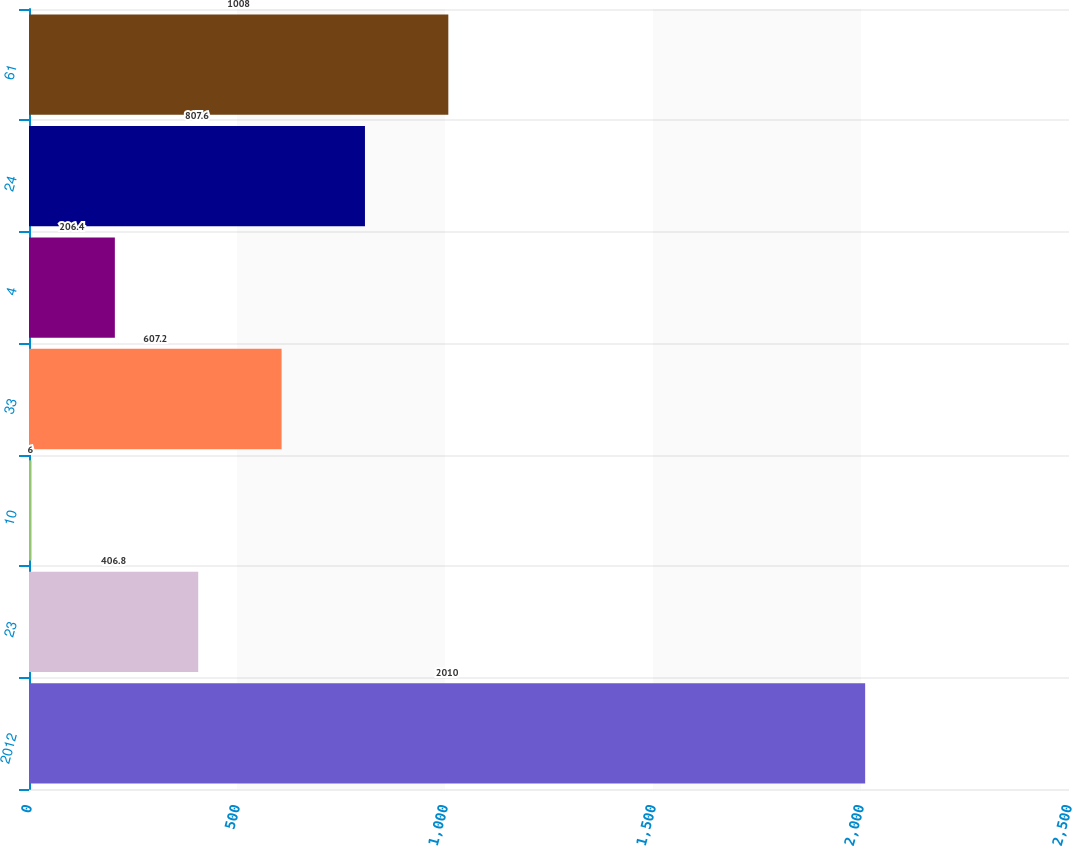<chart> <loc_0><loc_0><loc_500><loc_500><bar_chart><fcel>2012<fcel>23<fcel>10<fcel>33<fcel>4<fcel>24<fcel>61<nl><fcel>2010<fcel>406.8<fcel>6<fcel>607.2<fcel>206.4<fcel>807.6<fcel>1008<nl></chart> 